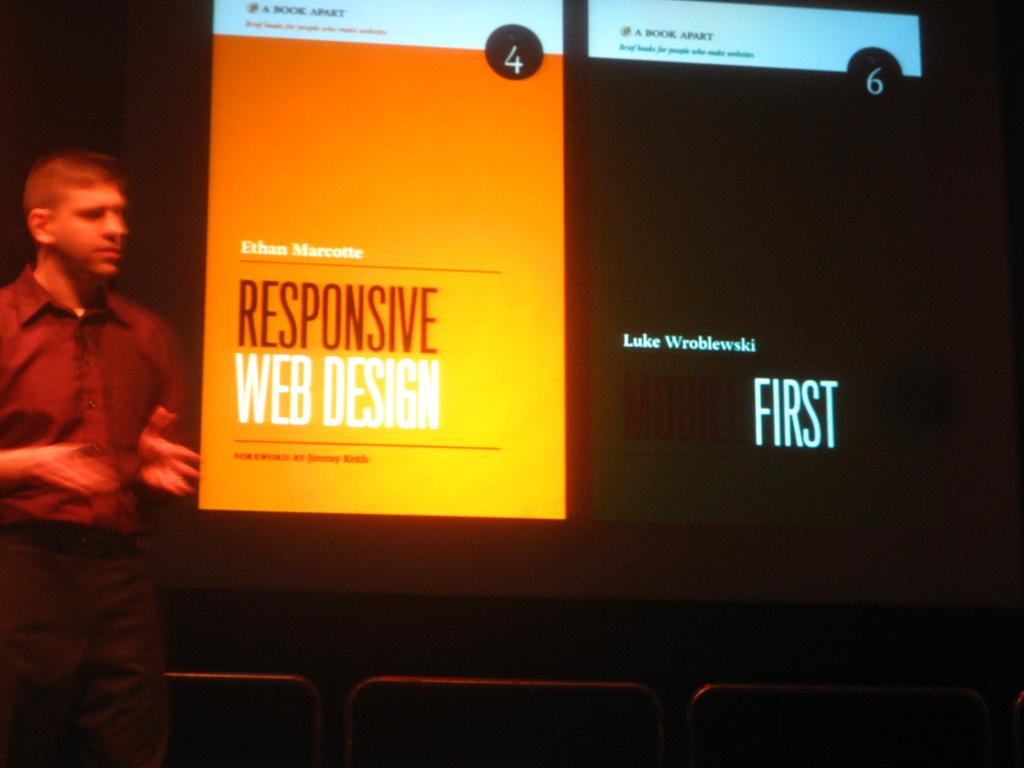Who is on the left side of the image? There is a man on the left side of the image. What is in the middle of the image? There is a screen in the middle of the image. What is being displayed on the screen? Something is presented on the screen. What are the chairs used for in the image? The chairs are at the bottom of the image, likely for seating. What type of thumb is being used to control the screen in the image? There is no thumb present in the image, and the screen is not being controlled by a thumb. What kind of soap is being used to clean the screen in the image? There is no soap present in the image, and the screen is not being cleaned. 